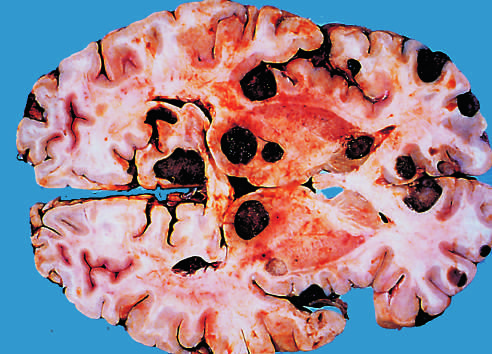re metastatic lesions distinguished grossly from most primary central nervous system tumors by their multicentricity and well-demarcated margins?
Answer the question using a single word or phrase. Yes 